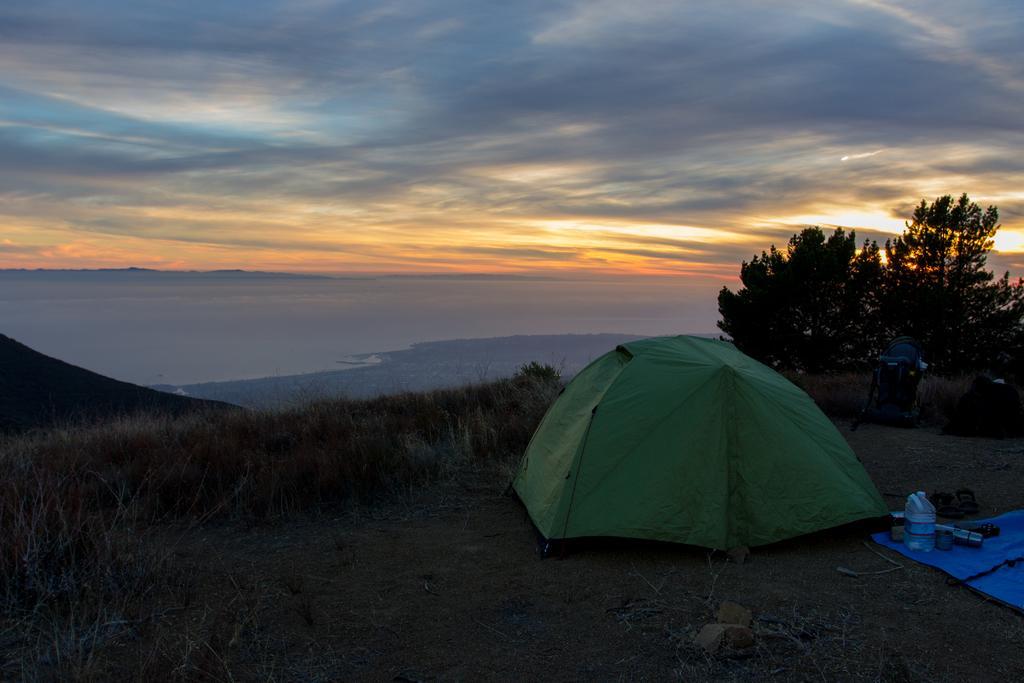Can you describe this image briefly? In the foreground I can see tent, wood sticks, grass, plants, trees, some objects on a cover and tents. In the background I can see mountains and the sky. This image is taken may be during night. 